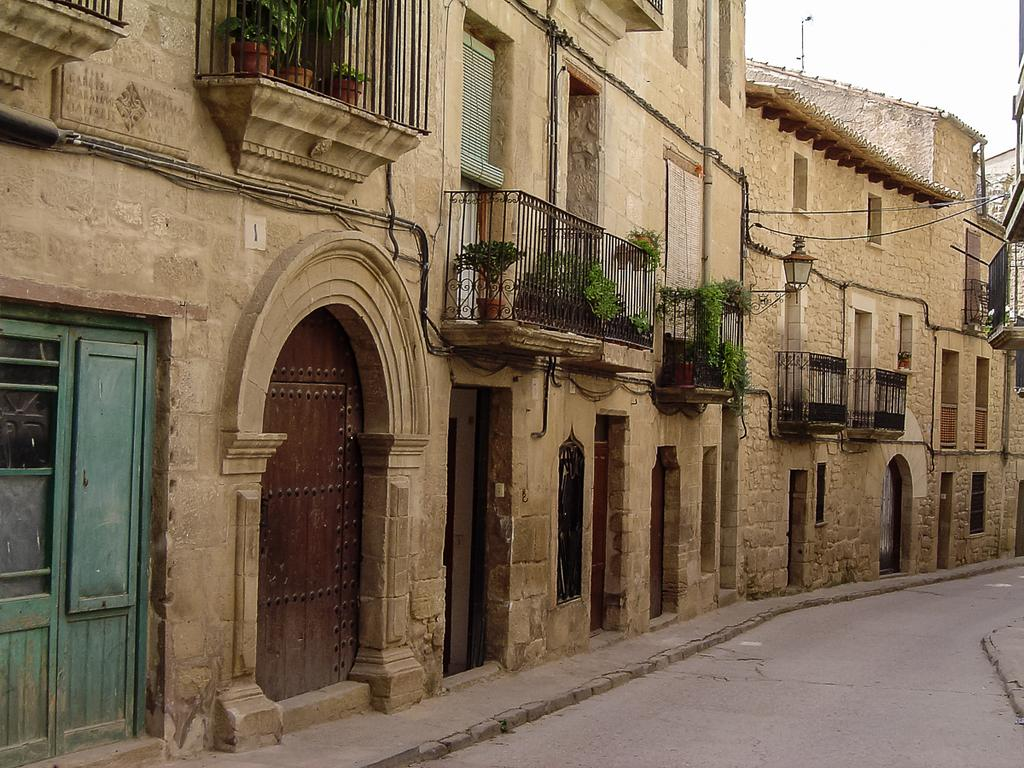What can be seen in the center of the image? The sky is visible in the center of the image. What type of structures are present in the image? There are buildings in the image. What type of barrier can be seen in the image? Fences are present in the image. What type of vegetation is in the image? There are pots with plants in the image. What type of openings are visible in the image? Doors are visible in the image. What type of pathway is present in the image? A road is present in the image. How many objects can be counted in the image? There are a few objects in the image. How many clovers are growing on the road in the image? There are no clovers present on the road in the image. What type of tree is visible in the image? There are no trees visible in the image. 